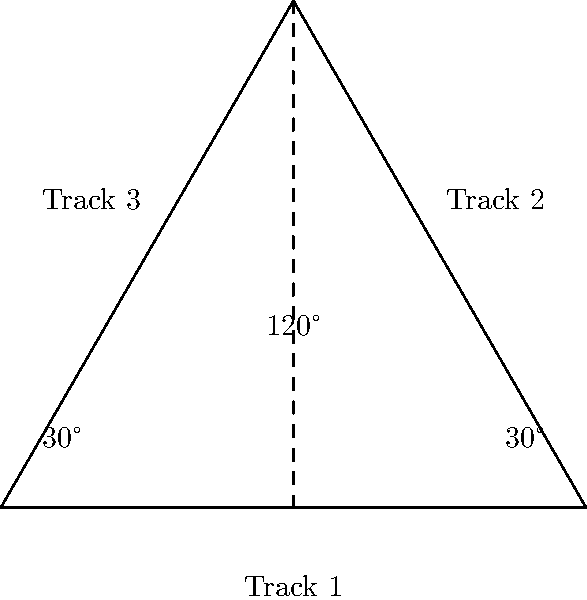At a railway junction, three tracks intersect as shown in the diagram. Track 1 and Track 2 form an angle of 120°. If Track 3 bisects the angle between Track 1 and Track 2, what is the angle between Track 1 and Track 3? Let's approach this step-by-step:

1) We're given that the angle between Track 1 and Track 2 is 120°.

2) We're also told that Track 3 bisects this angle. To bisect means to divide into two equal parts.

3) Therefore, the angle between Track 1 and Track 3 will be half of the total angle between Track 1 and Track 2.

4) We can set up the equation:
   $$\text{Angle between Track 1 and Track 3} = \frac{120°}{2}$$

5) Solving this equation:
   $$\text{Angle between Track 1 and Track 3} = 60°$$

Thus, the angle between Track 1 and Track 3 is 60°.
Answer: 60° 